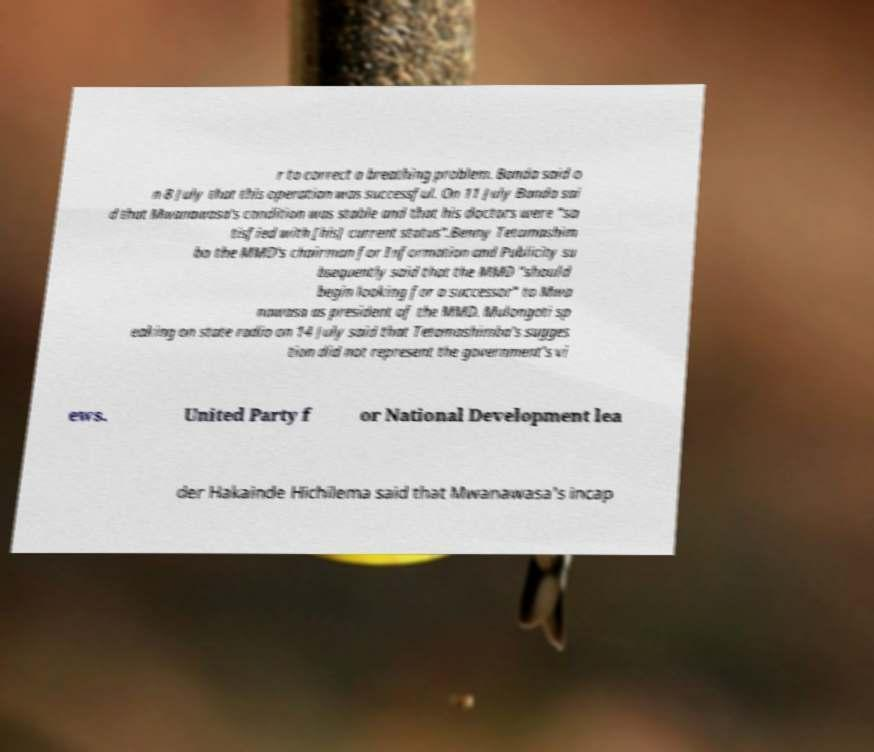For documentation purposes, I need the text within this image transcribed. Could you provide that? r to correct a breathing problem. Banda said o n 8 July that this operation was successful. On 11 July Banda sai d that Mwanawasa's condition was stable and that his doctors were "sa tisfied with [his] current status".Benny Tetamashim ba the MMD's chairman for Information and Publicity su bsequently said that the MMD "should begin looking for a successor" to Mwa nawasa as president of the MMD. Mulongoti sp eaking on state radio on 14 July said that Tetamashimba's sugges tion did not represent the government's vi ews. United Party f or National Development lea der Hakainde Hichilema said that Mwanawasa's incap 